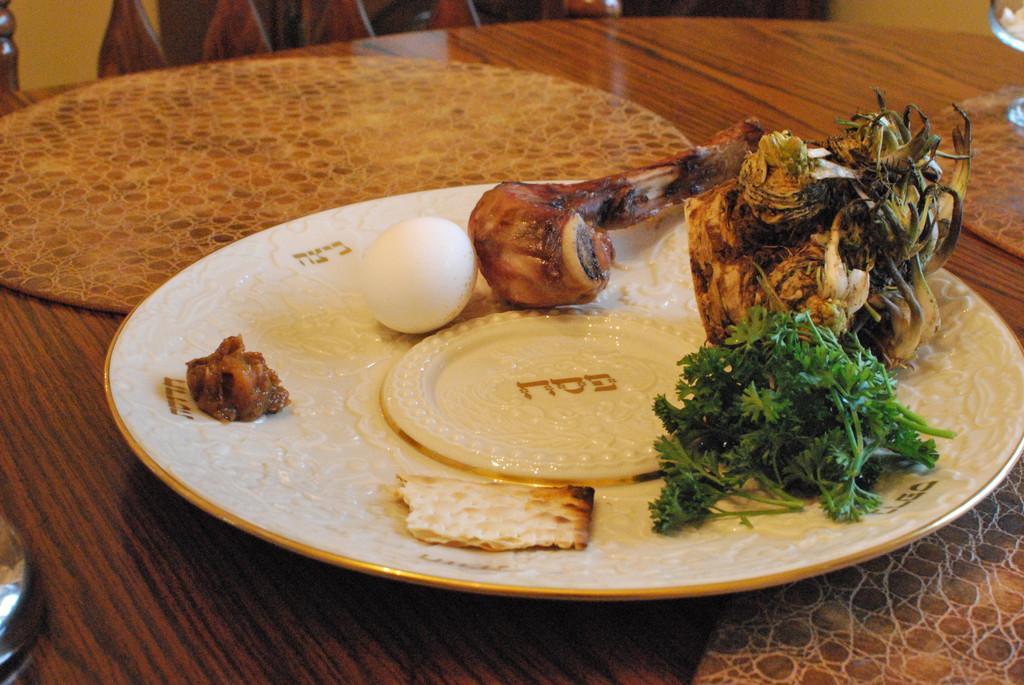Describe this image in one or two sentences. In this picture we can see a table, there is a plate present on the table, we can see some food, an egg and mint leaves present in this plate. 